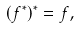Convert formula to latex. <formula><loc_0><loc_0><loc_500><loc_500>( f ^ { * } ) ^ { * } = f ,</formula> 